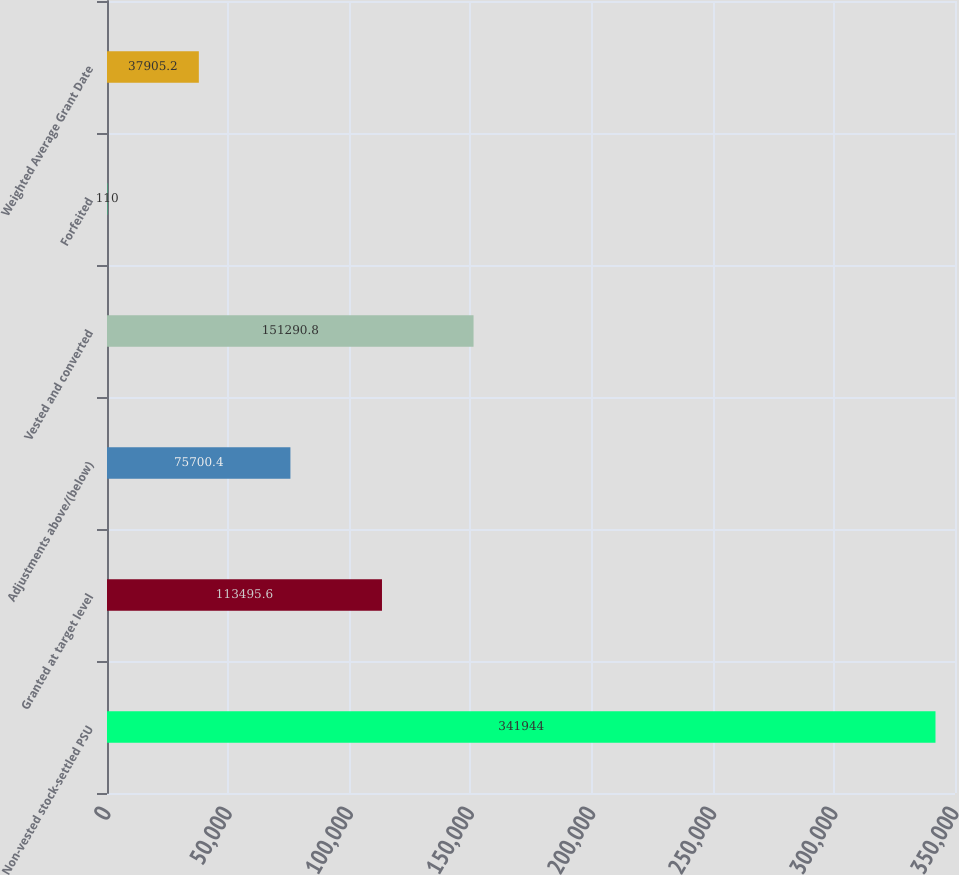<chart> <loc_0><loc_0><loc_500><loc_500><bar_chart><fcel>Non-vested stock-settled PSU<fcel>Granted at target level<fcel>Adjustments above/(below)<fcel>Vested and converted<fcel>Forfeited<fcel>Weighted Average Grant Date<nl><fcel>341944<fcel>113496<fcel>75700.4<fcel>151291<fcel>110<fcel>37905.2<nl></chart> 